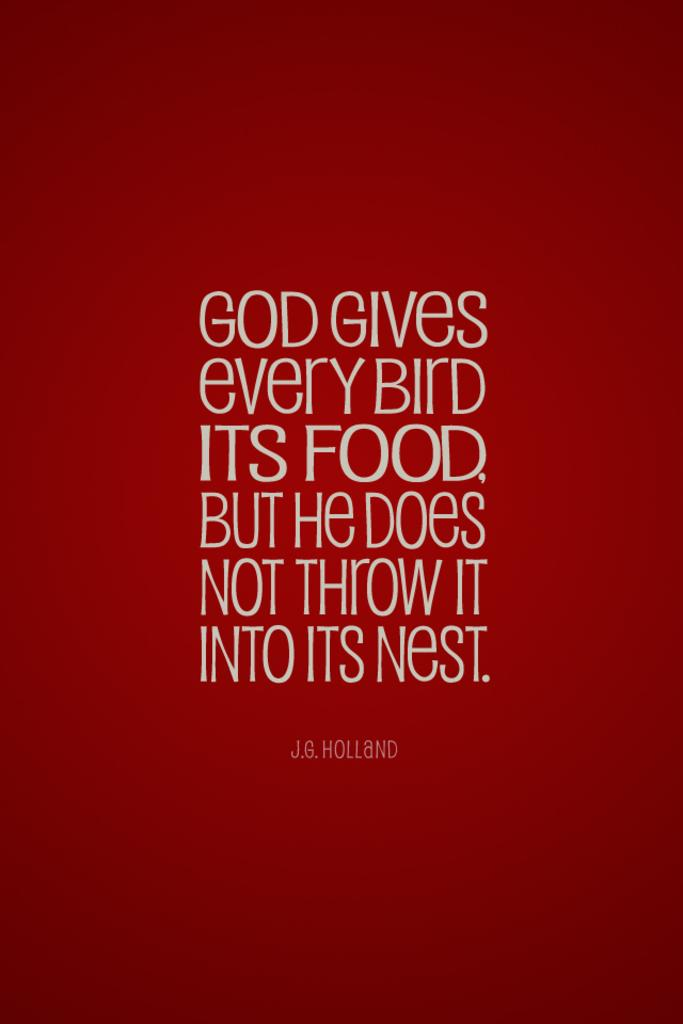<image>
Share a concise interpretation of the image provided. a quote with a red background that is from J.B. Holland 